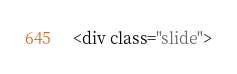<code> <loc_0><loc_0><loc_500><loc_500><_HTML_>
<div class="slide"></code> 